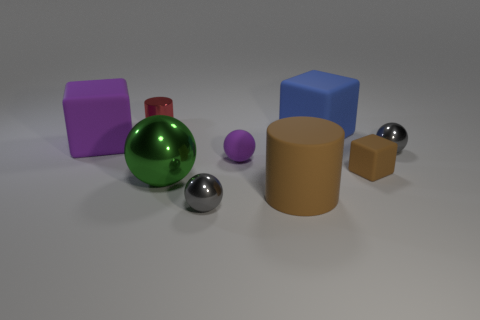What is the shape of the thing that is the same color as the big matte cylinder?
Your response must be concise. Cube. There is a matte cylinder that is the same color as the small cube; what is its size?
Ensure brevity in your answer.  Large. How many large matte blocks are the same color as the big cylinder?
Your response must be concise. 0. How big is the purple sphere?
Keep it short and to the point. Small. Does the red thing have the same size as the blue rubber cube?
Your response must be concise. No. What color is the cube that is in front of the big blue matte cube and on the right side of the tiny metallic cylinder?
Your answer should be very brief. Brown. How many tiny cylinders have the same material as the large purple block?
Make the answer very short. 0. How many gray objects are there?
Provide a short and direct response. 2. Do the green metallic thing and the purple rubber object that is in front of the purple rubber cube have the same size?
Your answer should be very brief. No. There is a small gray thing that is in front of the gray metal ball to the right of the small brown cube; what is it made of?
Give a very brief answer. Metal. 